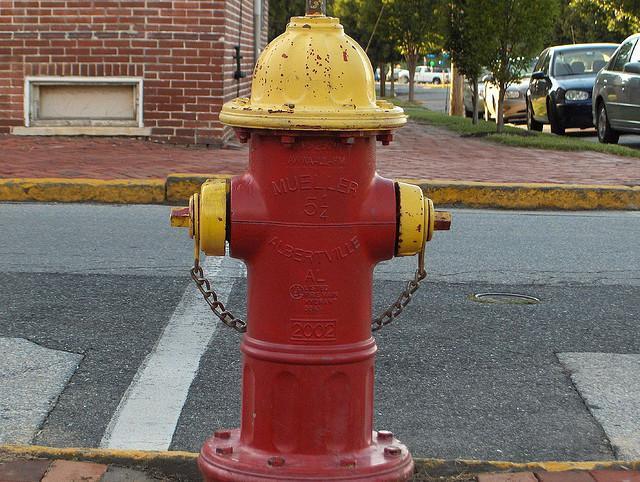How many colors is the fire hydrant?
Give a very brief answer. 2. How many cars are there?
Give a very brief answer. 2. How many open laptops are visible in this photo?
Give a very brief answer. 0. 